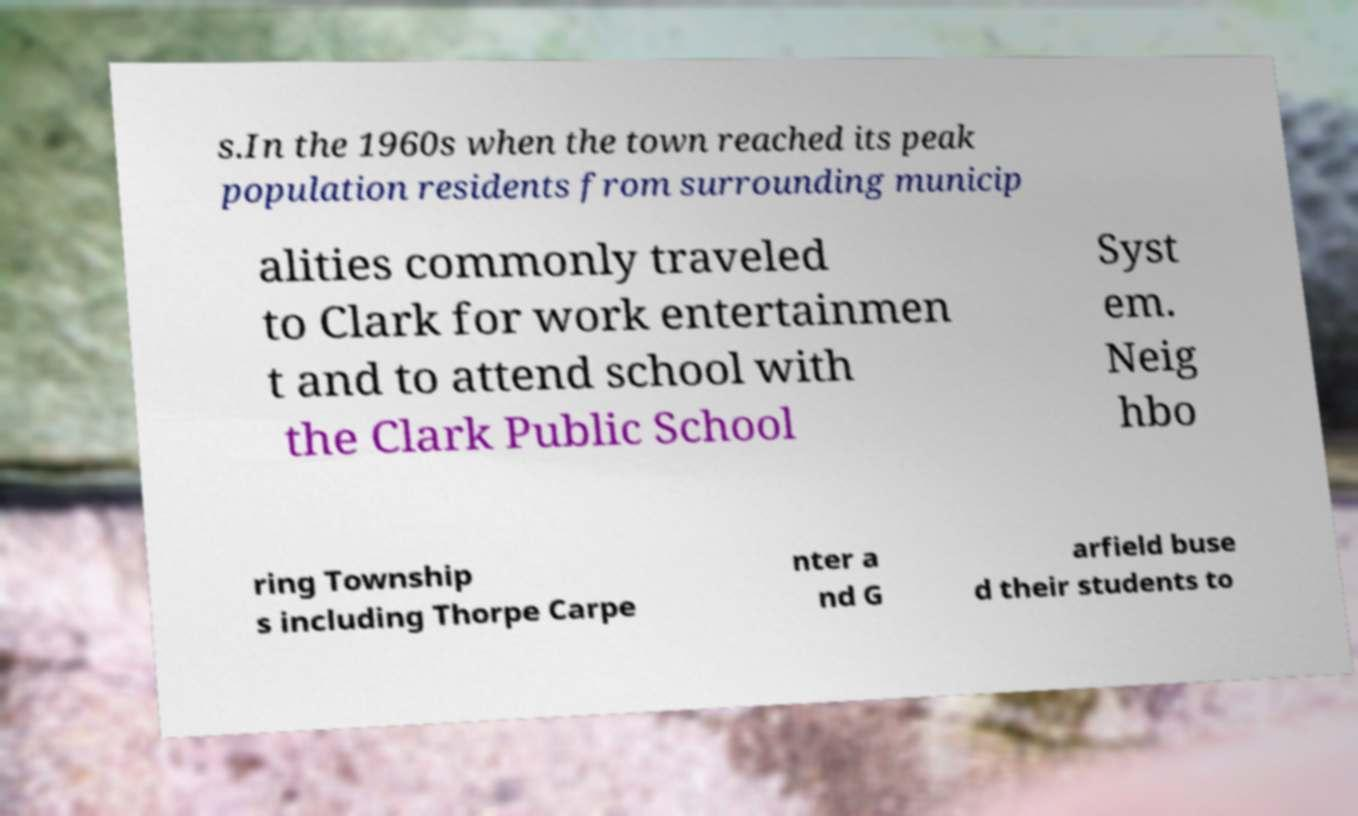There's text embedded in this image that I need extracted. Can you transcribe it verbatim? s.In the 1960s when the town reached its peak population residents from surrounding municip alities commonly traveled to Clark for work entertainmen t and to attend school with the Clark Public School Syst em. Neig hbo ring Township s including Thorpe Carpe nter a nd G arfield buse d their students to 